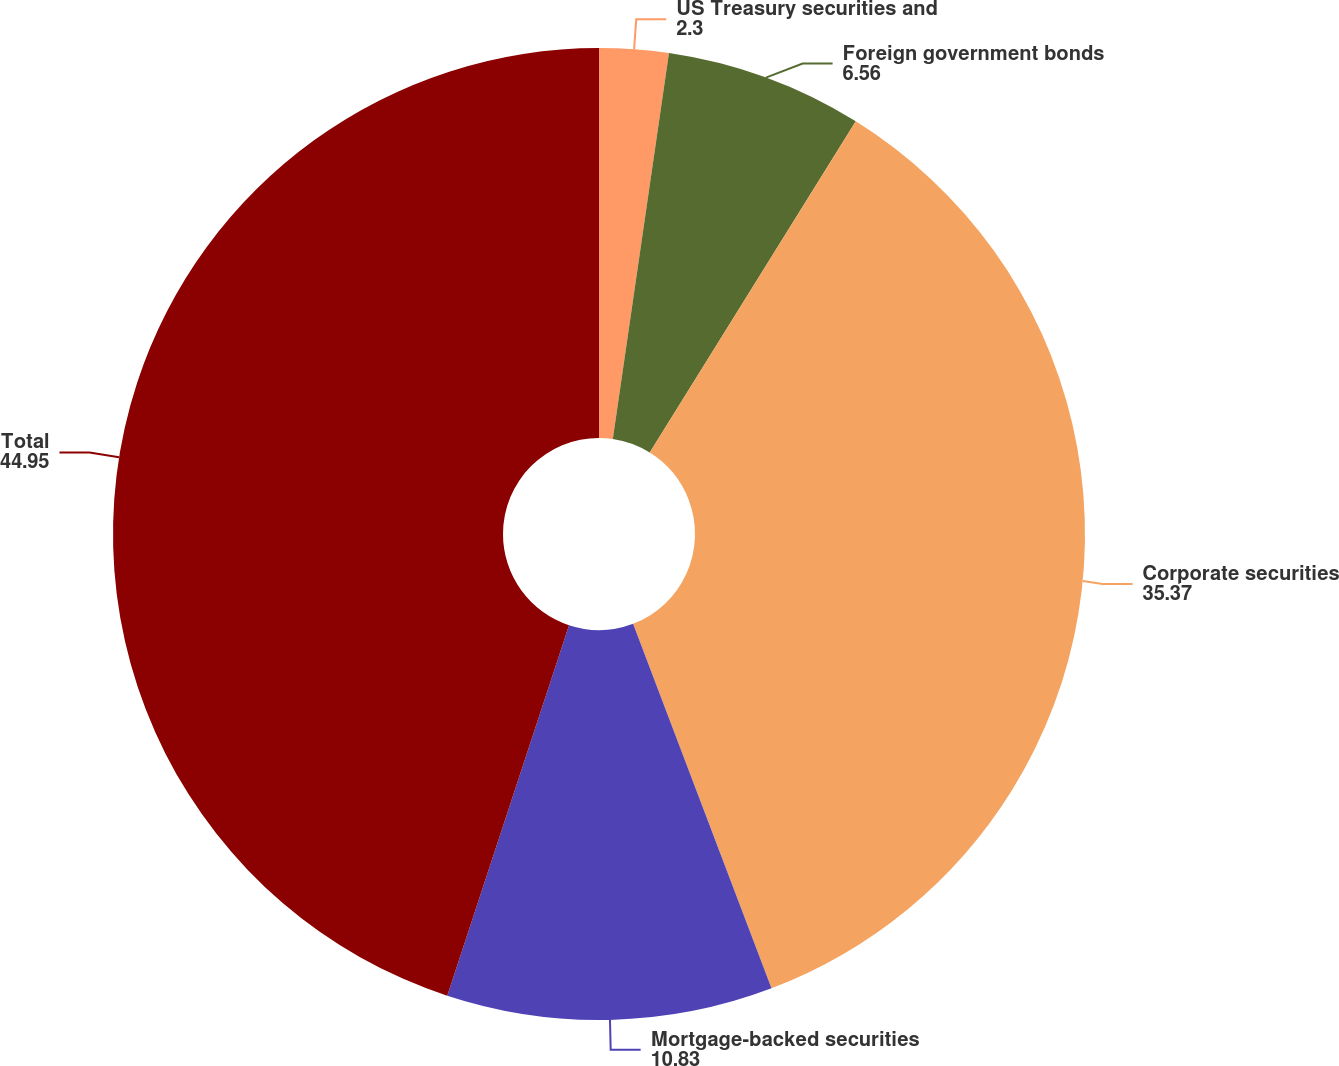Convert chart to OTSL. <chart><loc_0><loc_0><loc_500><loc_500><pie_chart><fcel>US Treasury securities and<fcel>Foreign government bonds<fcel>Corporate securities<fcel>Mortgage-backed securities<fcel>Total<nl><fcel>2.3%<fcel>6.56%<fcel>35.37%<fcel>10.83%<fcel>44.95%<nl></chart> 